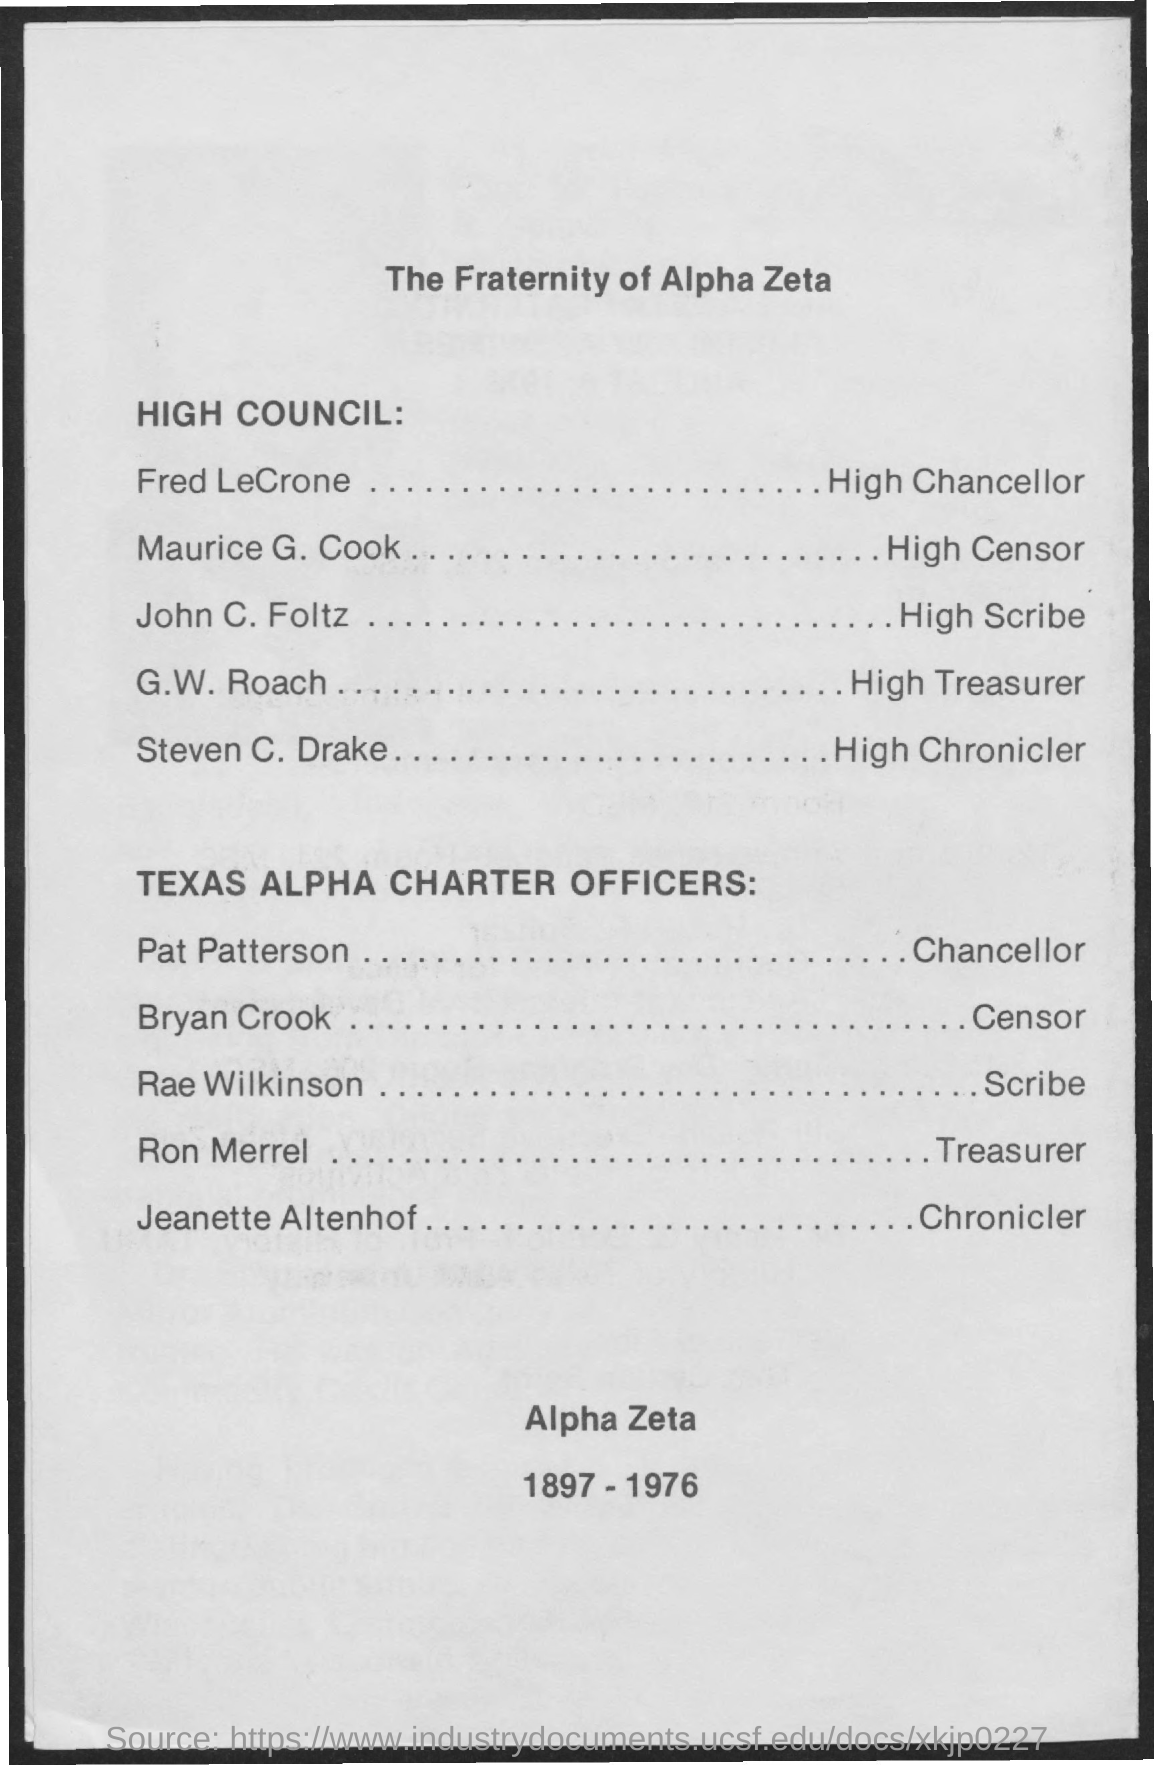What is the Title of the document?
Your answer should be very brief. The fraternity of alpha zeta. Who is the High Chancellor?
Your answer should be very brief. Fred lecrone. 